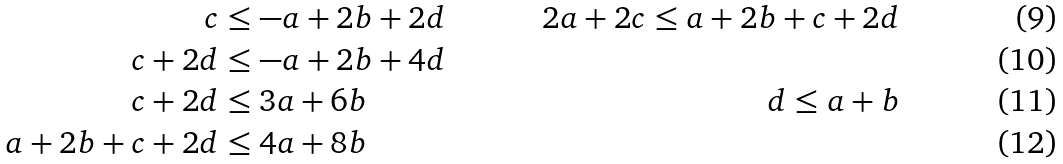Convert formula to latex. <formula><loc_0><loc_0><loc_500><loc_500>c & \leq - a + 2 b + 2 d & 2 a + 2 c \leq a + 2 b + c + 2 d \\ c + 2 d & \leq - a + 2 b + 4 d \\ c + 2 d & \leq 3 a + 6 b & d \leq a + b \\ a + 2 b + c + 2 d & \leq 4 a + 8 b</formula> 